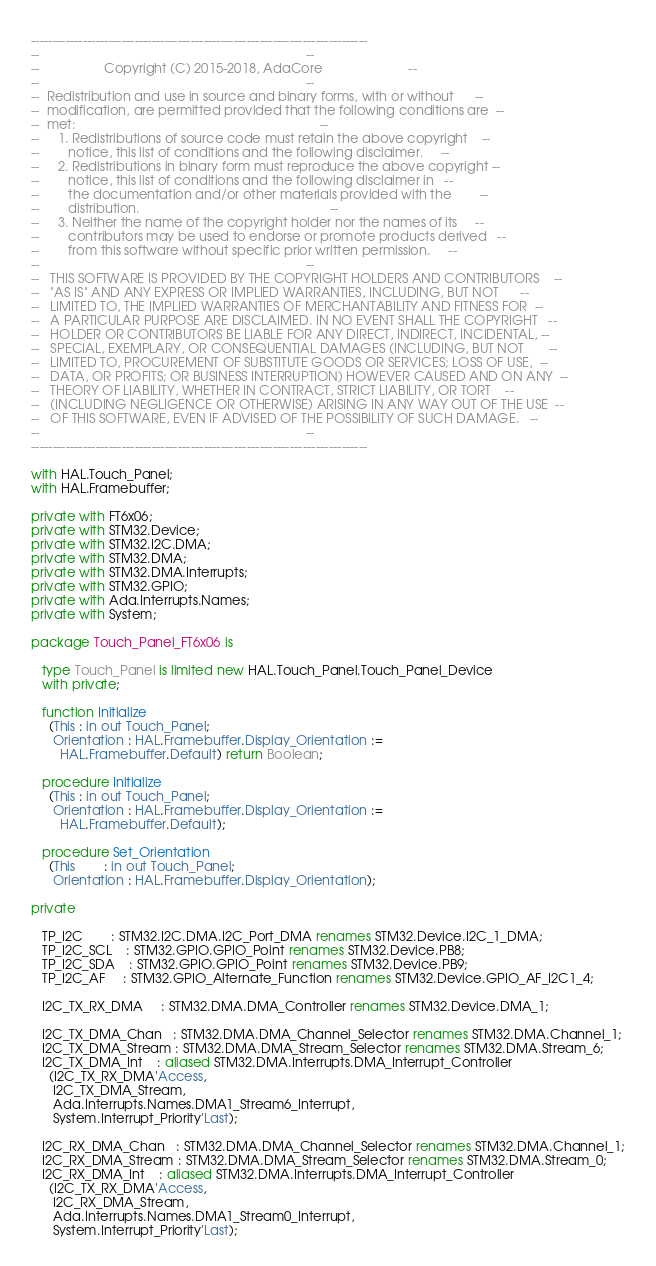<code> <loc_0><loc_0><loc_500><loc_500><_Ada_>------------------------------------------------------------------------------
--                                                                          --
--                  Copyright (C) 2015-2018, AdaCore                        --
--                                                                          --
--  Redistribution and use in source and binary forms, with or without      --
--  modification, are permitted provided that the following conditions are  --
--  met:                                                                    --
--     1. Redistributions of source code must retain the above copyright    --
--        notice, this list of conditions and the following disclaimer.     --
--     2. Redistributions in binary form must reproduce the above copyright --
--        notice, this list of conditions and the following disclaimer in   --
--        the documentation and/or other materials provided with the        --
--        distribution.                                                     --
--     3. Neither the name of the copyright holder nor the names of its     --
--        contributors may be used to endorse or promote products derived   --
--        from this software without specific prior written permission.     --
--                                                                          --
--   THIS SOFTWARE IS PROVIDED BY THE COPYRIGHT HOLDERS AND CONTRIBUTORS    --
--   "AS IS" AND ANY EXPRESS OR IMPLIED WARRANTIES, INCLUDING, BUT NOT      --
--   LIMITED TO, THE IMPLIED WARRANTIES OF MERCHANTABILITY AND FITNESS FOR  --
--   A PARTICULAR PURPOSE ARE DISCLAIMED. IN NO EVENT SHALL THE COPYRIGHT   --
--   HOLDER OR CONTRIBUTORS BE LIABLE FOR ANY DIRECT, INDIRECT, INCIDENTAL, --
--   SPECIAL, EXEMPLARY, OR CONSEQUENTIAL DAMAGES (INCLUDING, BUT NOT       --
--   LIMITED TO, PROCUREMENT OF SUBSTITUTE GOODS OR SERVICES; LOSS OF USE,  --
--   DATA, OR PROFITS; OR BUSINESS INTERRUPTION) HOWEVER CAUSED AND ON ANY  --
--   THEORY OF LIABILITY, WHETHER IN CONTRACT, STRICT LIABILITY, OR TORT    --
--   (INCLUDING NEGLIGENCE OR OTHERWISE) ARISING IN ANY WAY OUT OF THE USE  --
--   OF THIS SOFTWARE, EVEN IF ADVISED OF THE POSSIBILITY OF SUCH DAMAGE.   --
--                                                                          --
------------------------------------------------------------------------------

with HAL.Touch_Panel;
with HAL.Framebuffer;

private with FT6x06;
private with STM32.Device;
private with STM32.I2C.DMA;
private with STM32.DMA;
private with STM32.DMA.Interrupts;
private with STM32.GPIO;
private with Ada.Interrupts.Names;
private with System;

package Touch_Panel_FT6x06 is

   type Touch_Panel is limited new HAL.Touch_Panel.Touch_Panel_Device
   with private;

   function Initialize
     (This : in out Touch_Panel;
      Orientation : HAL.Framebuffer.Display_Orientation :=
        HAL.Framebuffer.Default) return Boolean;

   procedure Initialize
     (This : in out Touch_Panel;
      Orientation : HAL.Framebuffer.Display_Orientation :=
        HAL.Framebuffer.Default);

   procedure Set_Orientation
     (This        : in out Touch_Panel;
      Orientation : HAL.Framebuffer.Display_Orientation);

private

   TP_I2C        : STM32.I2C.DMA.I2C_Port_DMA renames STM32.Device.I2C_1_DMA;
   TP_I2C_SCL    : STM32.GPIO.GPIO_Point renames STM32.Device.PB8;
   TP_I2C_SDA    : STM32.GPIO.GPIO_Point renames STM32.Device.PB9;
   TP_I2C_AF     : STM32.GPIO_Alternate_Function renames STM32.Device.GPIO_AF_I2C1_4;

   I2C_TX_RX_DMA     : STM32.DMA.DMA_Controller renames STM32.Device.DMA_1;

   I2C_TX_DMA_Chan   : STM32.DMA.DMA_Channel_Selector renames STM32.DMA.Channel_1;
   I2C_TX_DMA_Stream : STM32.DMA.DMA_Stream_Selector renames STM32.DMA.Stream_6;
   I2C_TX_DMA_Int    : aliased STM32.DMA.Interrupts.DMA_Interrupt_Controller
     (I2C_TX_RX_DMA'Access,
      I2C_TX_DMA_Stream,
      Ada.Interrupts.Names.DMA1_Stream6_Interrupt,
      System.Interrupt_Priority'Last);

   I2C_RX_DMA_Chan   : STM32.DMA.DMA_Channel_Selector renames STM32.DMA.Channel_1;
   I2C_RX_DMA_Stream : STM32.DMA.DMA_Stream_Selector renames STM32.DMA.Stream_0;
   I2C_RX_DMA_Int    : aliased STM32.DMA.Interrupts.DMA_Interrupt_Controller
     (I2C_TX_RX_DMA'Access,
      I2C_RX_DMA_Stream,
      Ada.Interrupts.Names.DMA1_Stream0_Interrupt,
      System.Interrupt_Priority'Last);
</code> 